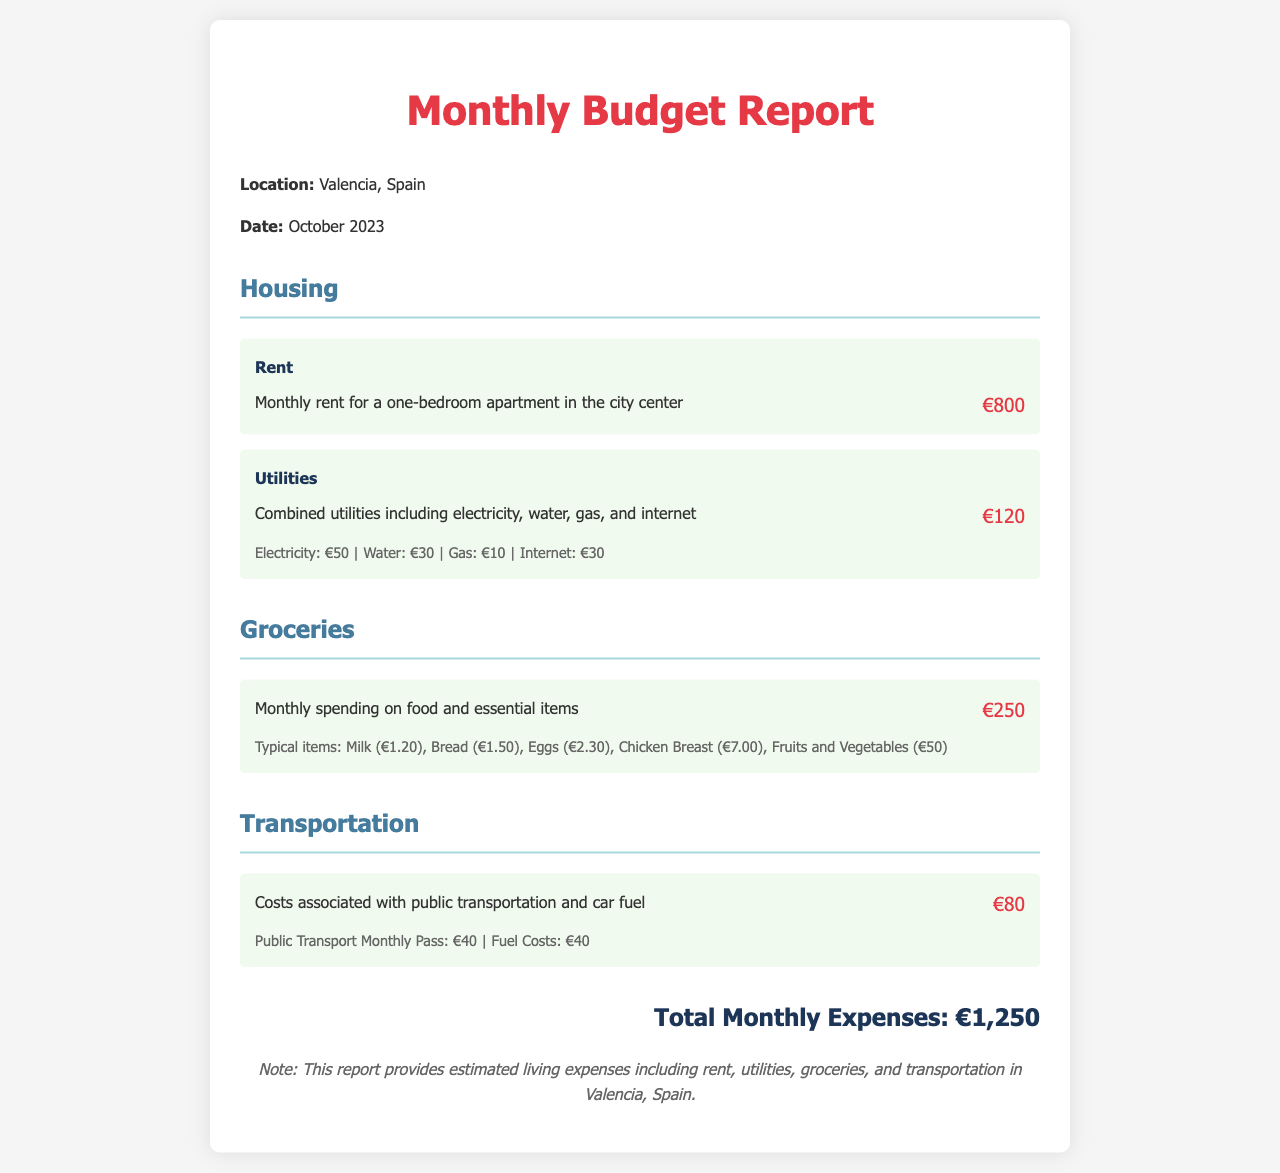what is the total monthly rent? The total monthly rent for a one-bedroom apartment in the city center is stated as €800.
Answer: €800 how much are the combined utilities? The combined utilities, including electricity, water, gas, and internet, are listed as €120.
Answer: €120 what is the monthly spending on groceries? The document specifies the monthly spending on food and essential items as €250.
Answer: €250 how much is the public transport monthly pass? The report indicates that the public transport monthly pass costs €40.
Answer: €40 what are the total monthly expenses? The total monthly expenses are calculated as €800 (rent) + €120 (utilities) + €250 (groceries) + €80 (transportation) = €1,250.
Answer: €1,250 what is the breakdown of electricity costs? The breakdown for electricity shows it costs €50 as part of the total utility expenses.
Answer: €50 what typical items are included in the groceries? Typical items include Milk (€1.20), Bread (€1.50), Eggs (€2.30), Chicken Breast (€7.00), and Fruits and Vegetables (€50).
Answer: Milk, Bread, Eggs, Chicken Breast, Fruits and Vegetables how much do fuel costs amount to in transportation? The document states that fuel costs are €40, part of the total transportation costs.
Answer: €40 when was this budget report created? The report indicates that it was created in October 2023.
Answer: October 2023 